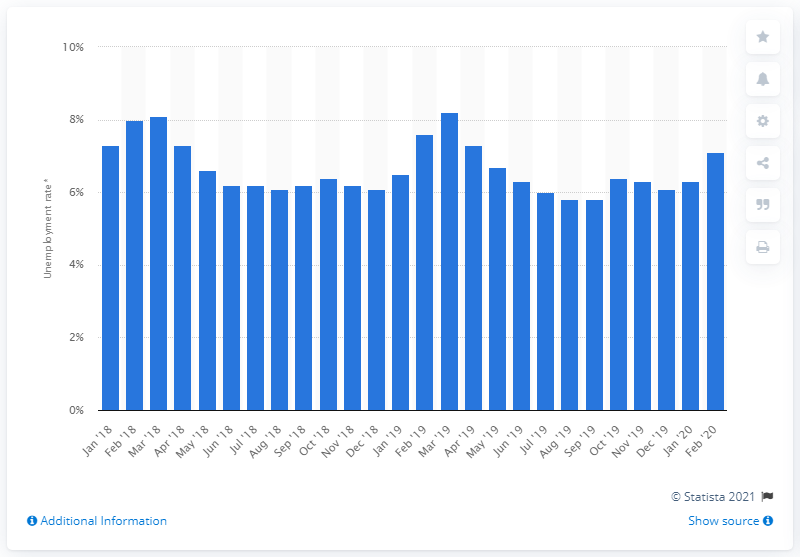Highlight a few significant elements in this photo. In February 2020, the unemployment rate in Lima was 7.1%. 